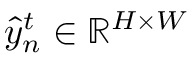Convert formula to latex. <formula><loc_0><loc_0><loc_500><loc_500>\hat { y } _ { n } ^ { t } \in \mathbb { R } ^ { H \times W }</formula> 